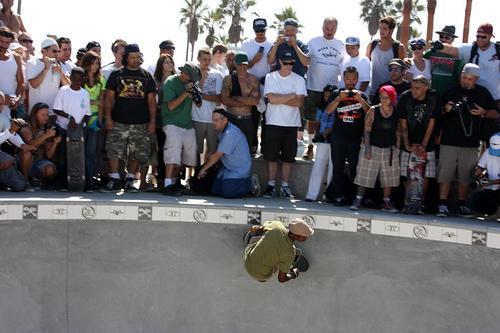How many people are there?
Give a very brief answer. 9. 